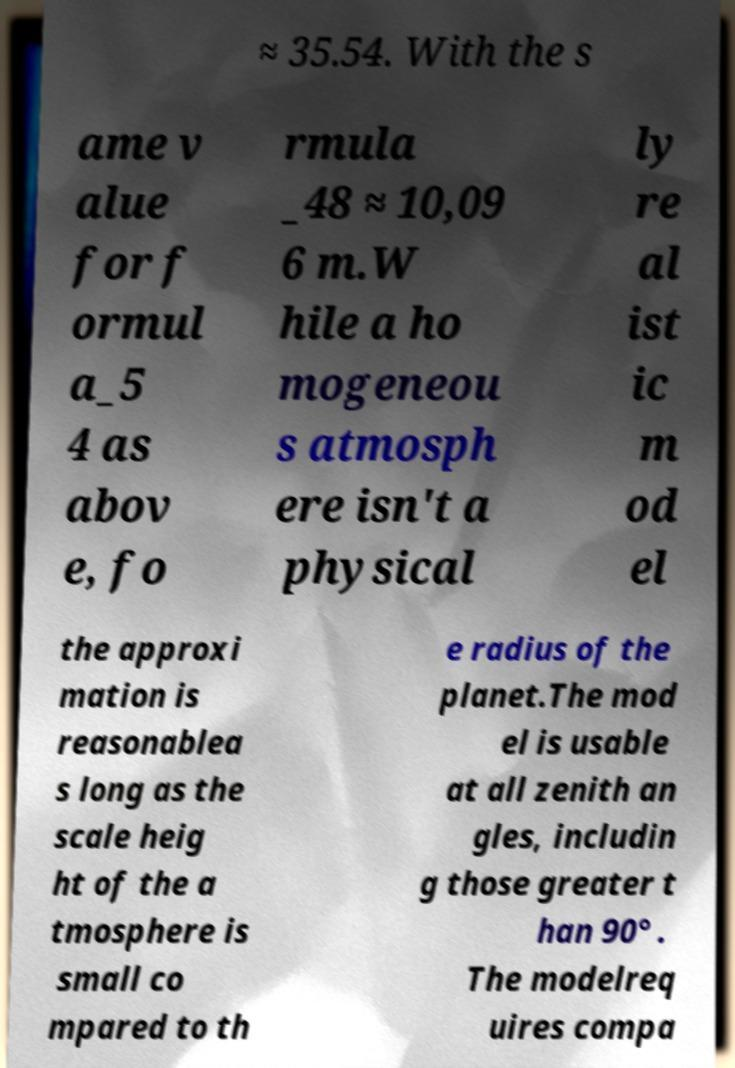Could you extract and type out the text from this image? ≈ 35.54. With the s ame v alue for f ormul a_5 4 as abov e, fo rmula _48 ≈ 10,09 6 m.W hile a ho mogeneou s atmosph ere isn't a physical ly re al ist ic m od el the approxi mation is reasonablea s long as the scale heig ht of the a tmosphere is small co mpared to th e radius of the planet.The mod el is usable at all zenith an gles, includin g those greater t han 90° . The modelreq uires compa 